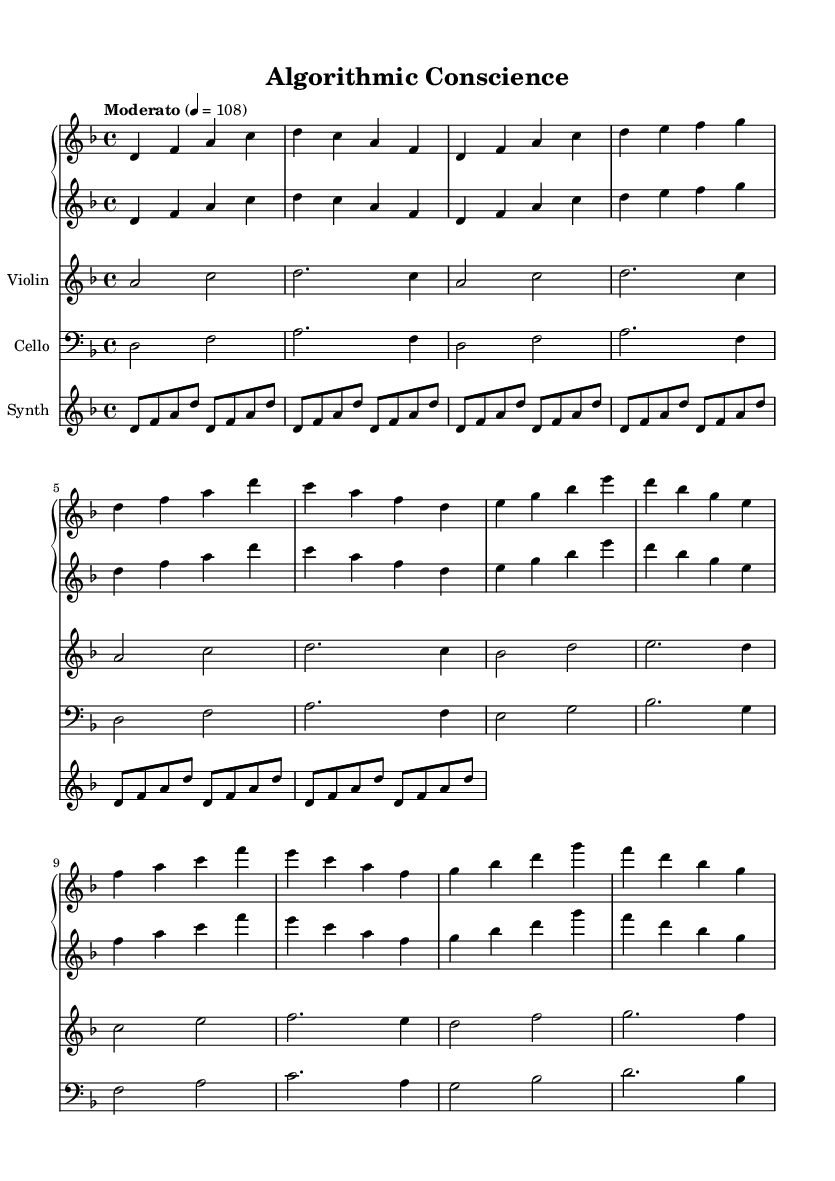What is the key signature of this music? The key signature is D minor, indicated by one flat (B flat) on the staff. The first symbol in the piece points to the key signature.
Answer: D minor What is the time signature of this music? The time signature is 4/4, shown at the beginning of the piece. It means there are four beats in each measure and a quarter note gets one beat.
Answer: 4/4 What is the tempo marking of this music? The tempo marking is "Moderato" with a metronome marking of 108 beats per minute, which is indicated at the start of the score.
Answer: Moderato, 108 How many measures are there in the piano part? Count the number of vertical lines marking measures in the piano part; there are 12 measures as indicated.
Answer: 12 Which instruments are present in this music? The music features piano, violin, cello, and synthesizer, as indicated by the different staffs labeled at the beginning of the score.
Answer: Piano, Violin, Cello, Synthesizer What is the rhythmic pattern in the synthesizer part? The synthesizer plays a repeated pattern of eighth notes consisting of D, F, A, and D, appearing in 12 repetitions.
Answer: Eighth notes Which classical techniques are seen in the cello part? The cello part uses techniques such as legato and sustained notes, evidenced by the use of whole and half notes throughout the measures.
Answer: Legato, sustained notes 